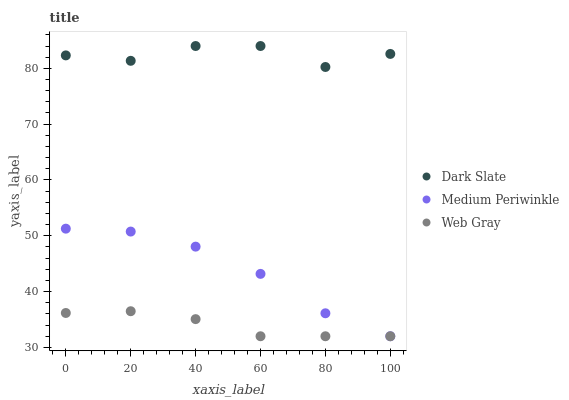Does Web Gray have the minimum area under the curve?
Answer yes or no. Yes. Does Dark Slate have the maximum area under the curve?
Answer yes or no. Yes. Does Medium Periwinkle have the minimum area under the curve?
Answer yes or no. No. Does Medium Periwinkle have the maximum area under the curve?
Answer yes or no. No. Is Web Gray the smoothest?
Answer yes or no. Yes. Is Dark Slate the roughest?
Answer yes or no. Yes. Is Medium Periwinkle the smoothest?
Answer yes or no. No. Is Medium Periwinkle the roughest?
Answer yes or no. No. Does Web Gray have the lowest value?
Answer yes or no. Yes. Does Dark Slate have the highest value?
Answer yes or no. Yes. Does Medium Periwinkle have the highest value?
Answer yes or no. No. Is Web Gray less than Dark Slate?
Answer yes or no. Yes. Is Dark Slate greater than Web Gray?
Answer yes or no. Yes. Does Medium Periwinkle intersect Web Gray?
Answer yes or no. Yes. Is Medium Periwinkle less than Web Gray?
Answer yes or no. No. Is Medium Periwinkle greater than Web Gray?
Answer yes or no. No. Does Web Gray intersect Dark Slate?
Answer yes or no. No. 